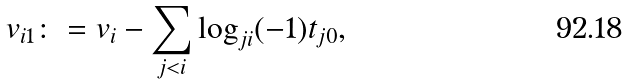Convert formula to latex. <formula><loc_0><loc_0><loc_500><loc_500>v _ { i 1 } \colon = v _ { i } - \sum _ { j < i } \log _ { j i } ( - 1 ) t _ { j 0 } ,</formula> 